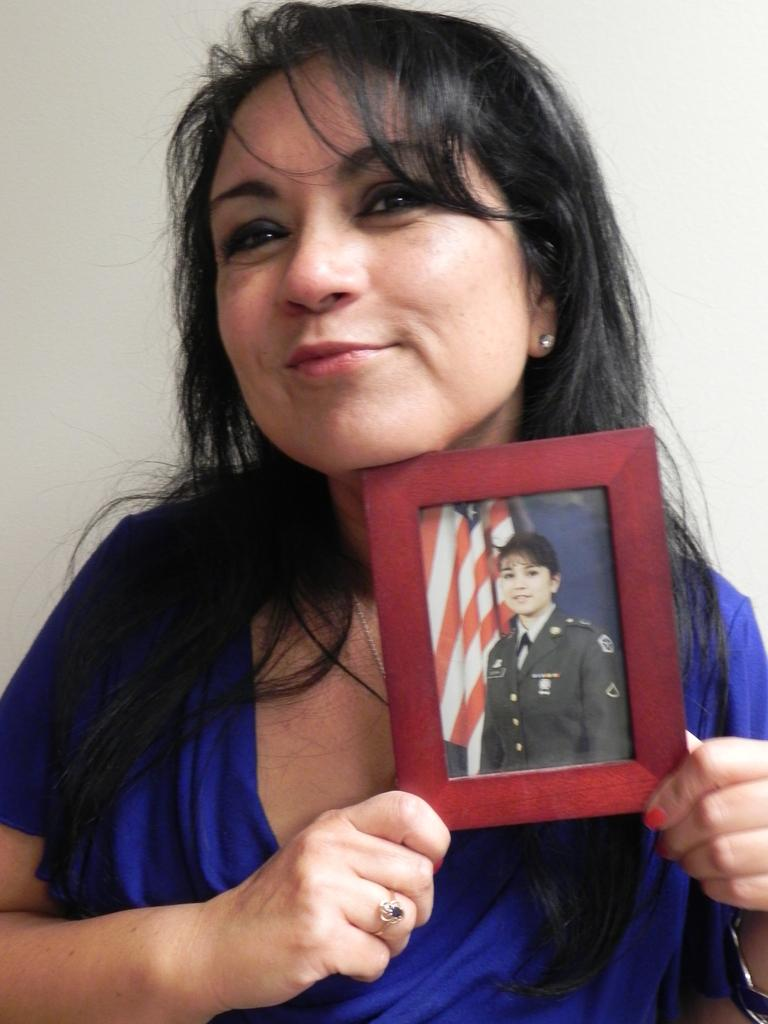Who is present in the image? There is a person in the image. What is the person holding in the image? The person is holding a photo frame. What type of motion is the person experiencing in the image? The image does not provide any information about the person's motion or movement. 